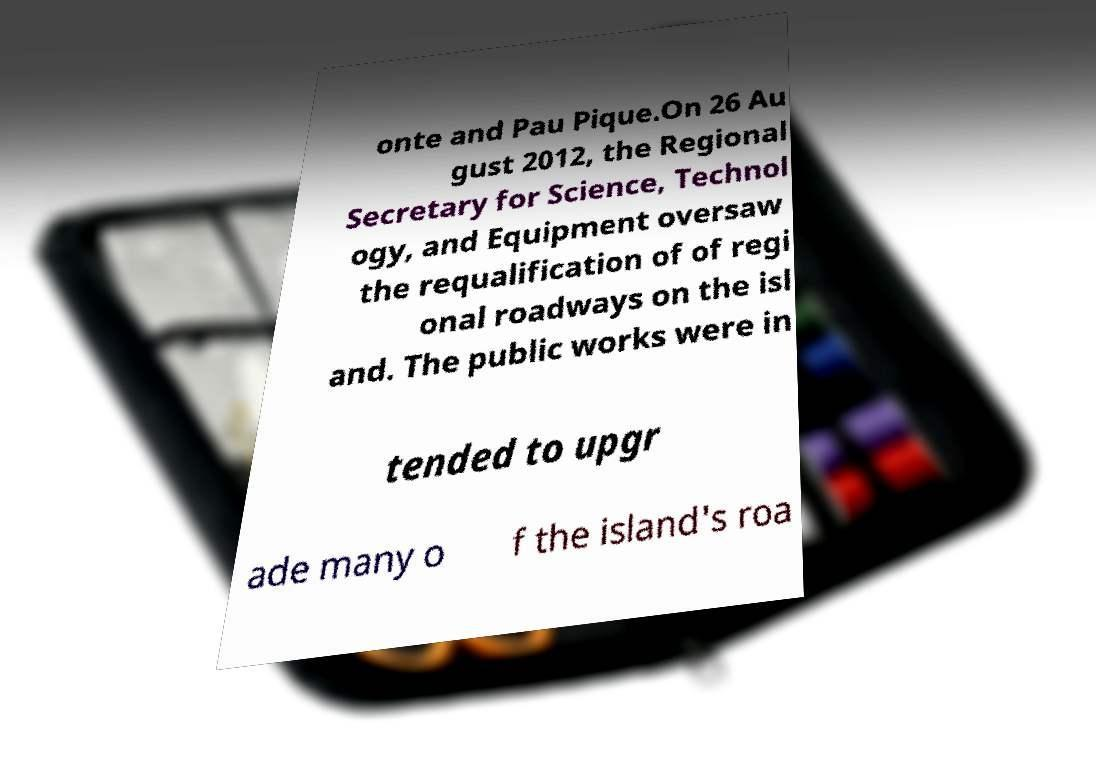Can you accurately transcribe the text from the provided image for me? onte and Pau Pique.On 26 Au gust 2012, the Regional Secretary for Science, Technol ogy, and Equipment oversaw the requalification of of regi onal roadways on the isl and. The public works were in tended to upgr ade many o f the island's roa 